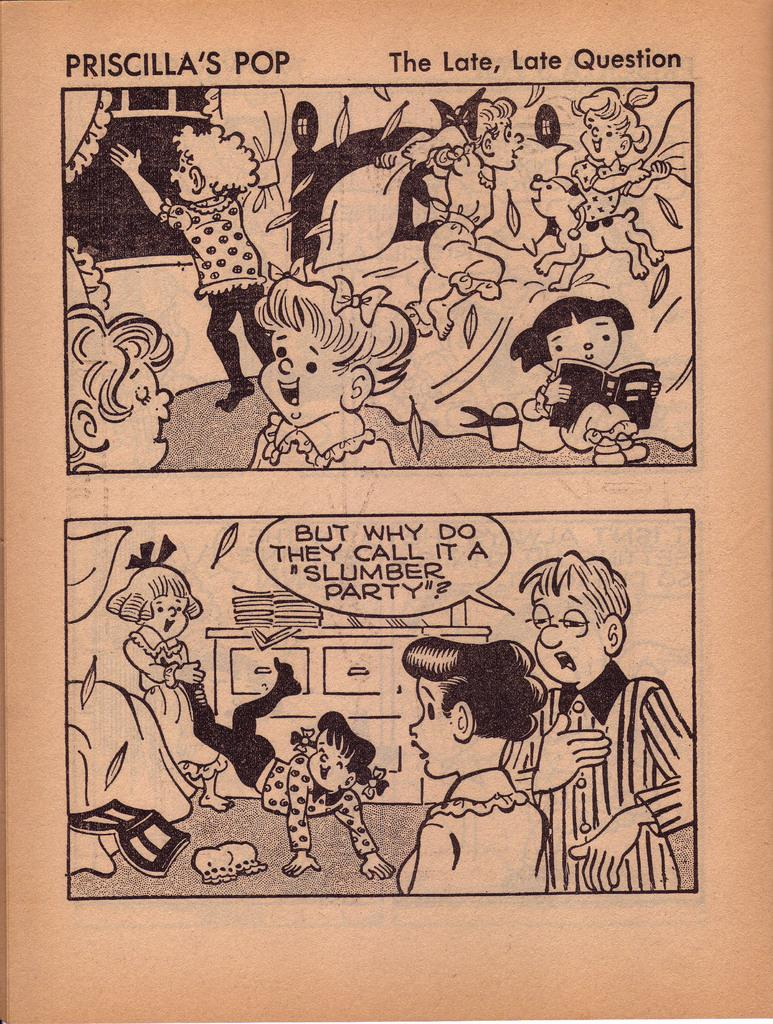Provide a one-sentence caption for the provided image. Comic book about Priscilla's Pop and The late late  question. 